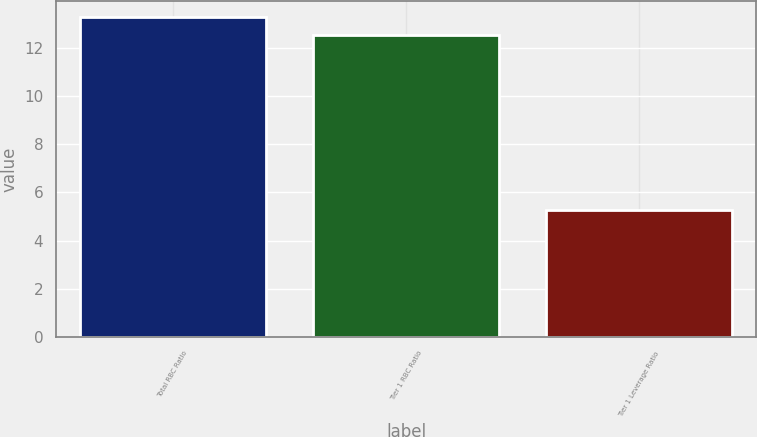<chart> <loc_0><loc_0><loc_500><loc_500><bar_chart><fcel>Total RBC Ratio<fcel>Tier 1 RBC Ratio<fcel>Tier 1 Leverage Ratio<nl><fcel>13.27<fcel>12.54<fcel>5.27<nl></chart> 